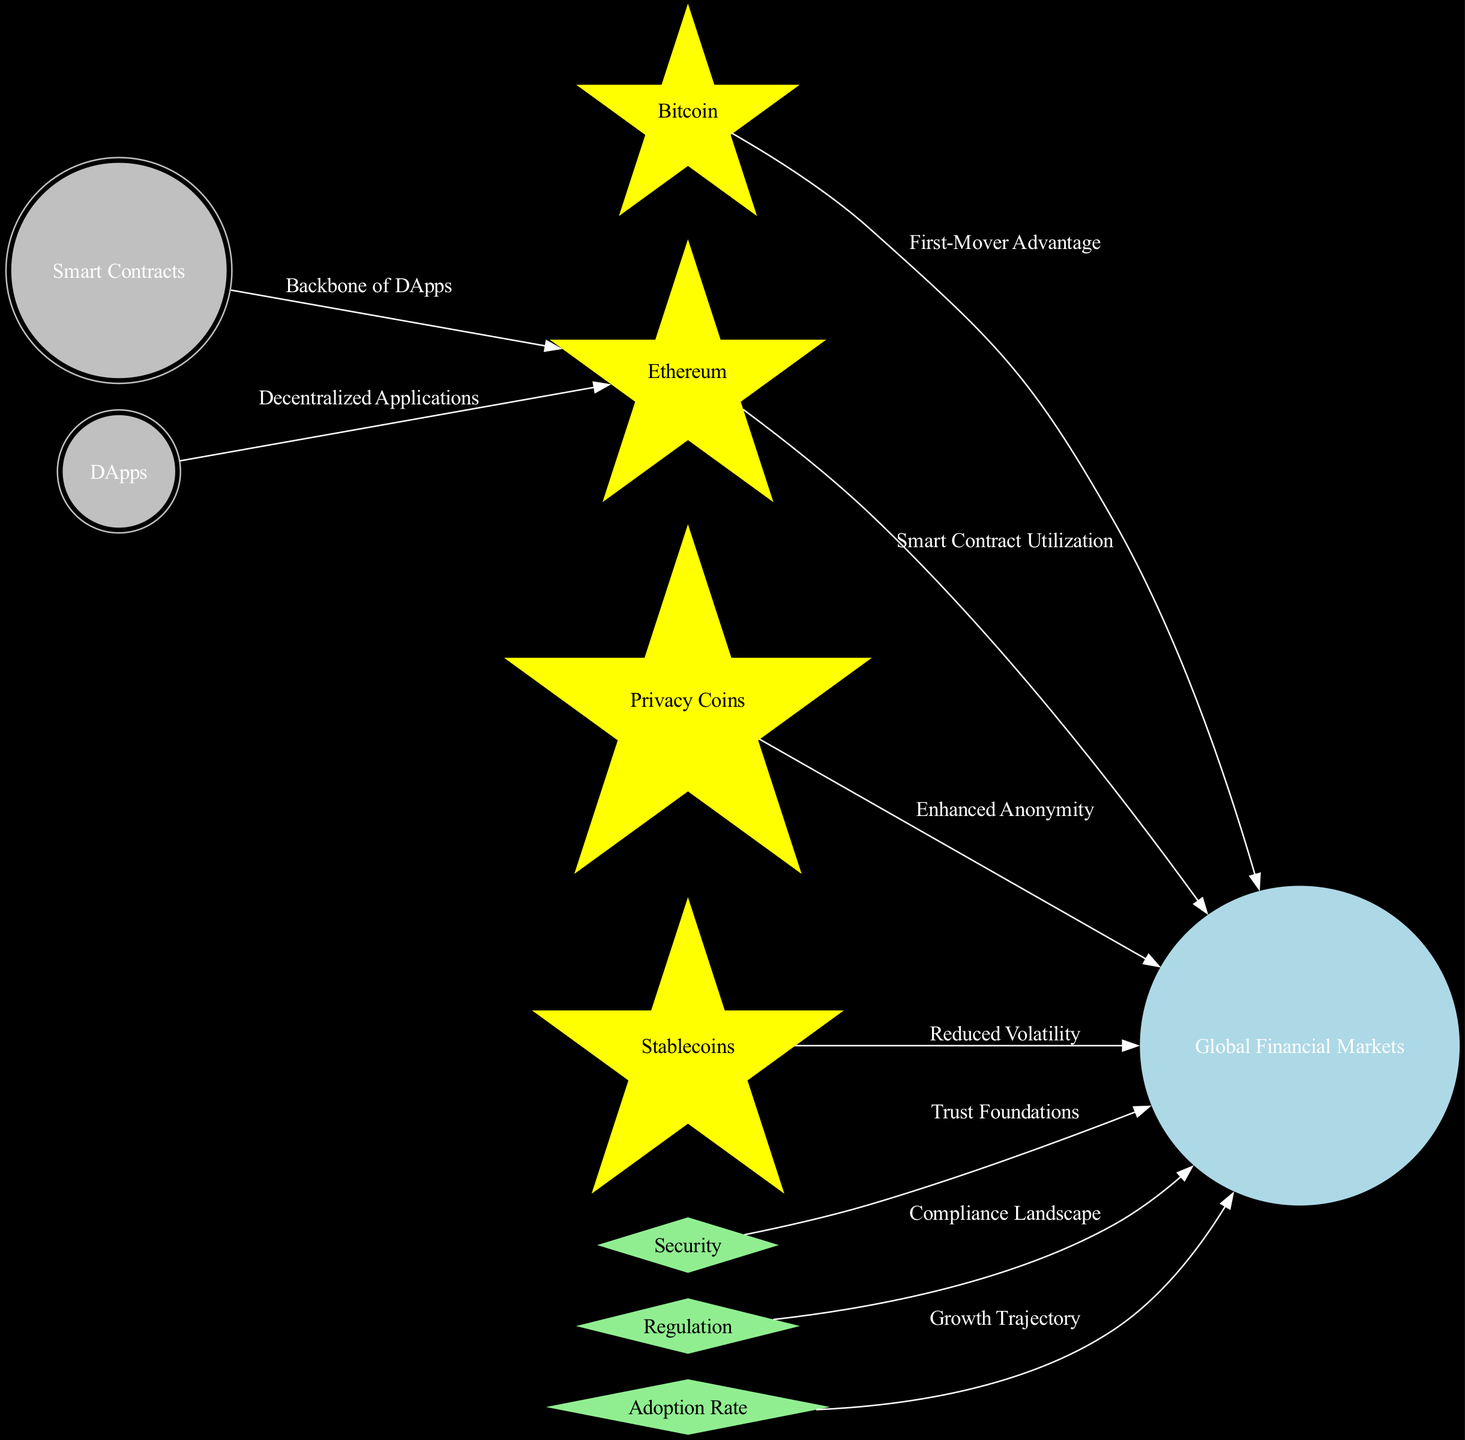What is the central node of the diagram? The central node is "Global Financial Markets," which is visually represented as a planet at the center of the diagram.
Answer: Global Financial Markets How many constellations are present in the diagram? There are three constellations: "Security," "Regulation," and "Adoption Rate." Each constellation is a separate node type that highlights key aspects of the cryptocurrency landscape.
Answer: 3 What relationship does "Bitcoin" have with "Global Financial Markets"? The relationship is characterized by the label "First-Mover Advantage," indicating that Bitcoin was the first significant cryptocurrency to establish itself in the market.
Answer: First-Mover Advantage Which node connects "Smart Contracts" and "Ethereum"? The edge connecting these two nodes is labeled "Backbone of DApps," which shows that Smart Contracts play a crucial role in the Ethereum ecosystem.
Answer: Backbone of DApps What does the label on the edge from "Privacy Coins" to "Global Financial Markets" denote? The label "Enhanced Anonymity" indicates that Privacy Coins contribute to increased confidentiality in transactions within the Global Financial Markets.
Answer: Enhanced Anonymity Which node is connected to "Adoption Rate"? The node connected to "Adoption Rate" is "Global Financial Markets." This edge signifies the growth trajectory of cryptocurrency adoption in the financial market space.
Answer: Global Financial Markets How many edges connect "Ethereum" to other nodes? "Ethereum" connects to two nodes: "Global Financial Markets" and "Smart Contracts." This shows Ethereum’s interactions within the ecosystem.
Answer: 2 What is the primary purpose of "Stablecoins" in relation to "Global Financial Markets"? The edge is labeled "Reduced Volatility," signifying that Stablecoins are used to stabilize the market and mitigate price fluctuations in cryptocurrency transactions.
Answer: Reduced Volatility Which asteroid belt is associated with "Ethereum"? The asteroid belt is "DApps," indicating that DApps rely on Ethereum’s smart contracts framework for their functionality and operation.
Answer: DApps What does the connection from "Regulation" to "Global Financial Markets" represent? This connection is labeled "Compliance Landscape," which implies the importance of regulatory frameworks in shaping the cryptocurrency market’s operation and legitimacy.
Answer: Compliance Landscape 